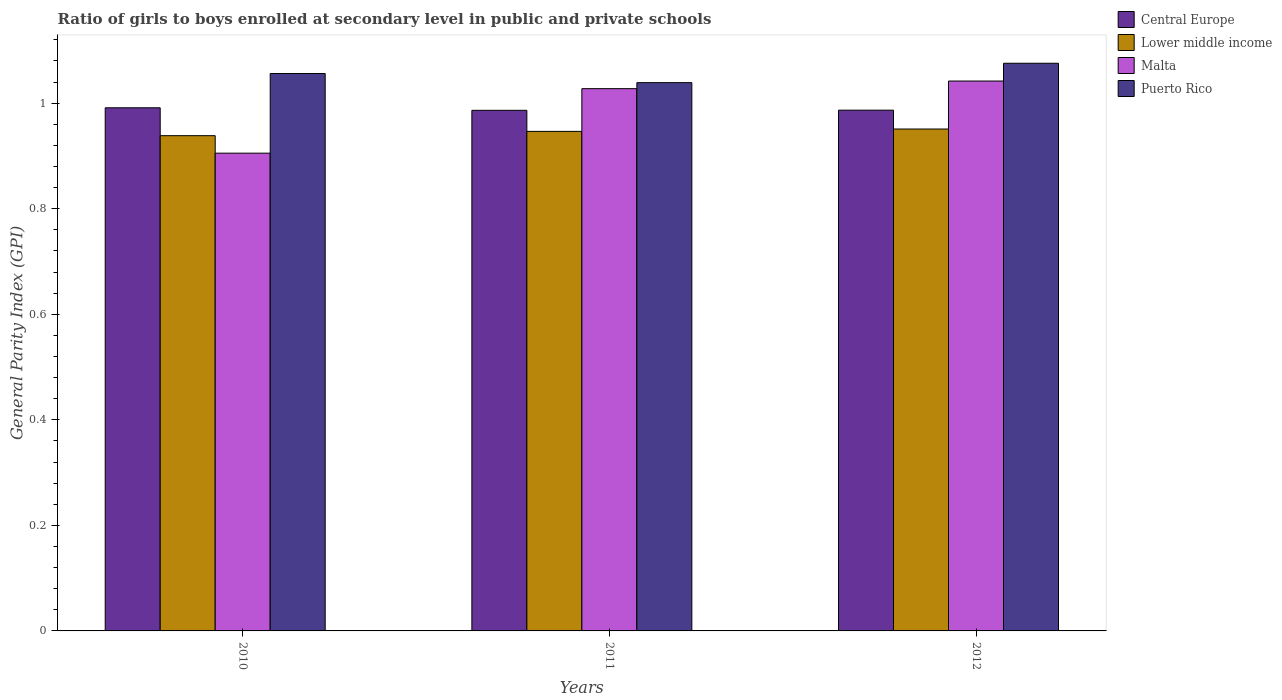How many different coloured bars are there?
Provide a short and direct response. 4. Are the number of bars per tick equal to the number of legend labels?
Give a very brief answer. Yes. Are the number of bars on each tick of the X-axis equal?
Make the answer very short. Yes. How many bars are there on the 3rd tick from the right?
Your response must be concise. 4. What is the general parity index in Lower middle income in 2010?
Offer a terse response. 0.94. Across all years, what is the maximum general parity index in Central Europe?
Provide a short and direct response. 0.99. Across all years, what is the minimum general parity index in Lower middle income?
Provide a short and direct response. 0.94. What is the total general parity index in Lower middle income in the graph?
Ensure brevity in your answer.  2.84. What is the difference between the general parity index in Lower middle income in 2010 and that in 2011?
Your answer should be very brief. -0.01. What is the difference between the general parity index in Lower middle income in 2010 and the general parity index in Central Europe in 2012?
Offer a terse response. -0.05. What is the average general parity index in Central Europe per year?
Offer a terse response. 0.99. In the year 2010, what is the difference between the general parity index in Lower middle income and general parity index in Puerto Rico?
Your answer should be compact. -0.12. What is the ratio of the general parity index in Malta in 2011 to that in 2012?
Your answer should be very brief. 0.99. Is the difference between the general parity index in Lower middle income in 2010 and 2011 greater than the difference between the general parity index in Puerto Rico in 2010 and 2011?
Keep it short and to the point. No. What is the difference between the highest and the second highest general parity index in Central Europe?
Provide a short and direct response. 0. What is the difference between the highest and the lowest general parity index in Central Europe?
Offer a very short reply. 0. What does the 4th bar from the left in 2010 represents?
Make the answer very short. Puerto Rico. What does the 1st bar from the right in 2012 represents?
Your answer should be very brief. Puerto Rico. Is it the case that in every year, the sum of the general parity index in Malta and general parity index in Puerto Rico is greater than the general parity index in Lower middle income?
Give a very brief answer. Yes. How many bars are there?
Provide a short and direct response. 12. What is the difference between two consecutive major ticks on the Y-axis?
Your response must be concise. 0.2. How many legend labels are there?
Your answer should be very brief. 4. What is the title of the graph?
Your answer should be compact. Ratio of girls to boys enrolled at secondary level in public and private schools. What is the label or title of the X-axis?
Offer a terse response. Years. What is the label or title of the Y-axis?
Your answer should be compact. General Parity Index (GPI). What is the General Parity Index (GPI) in Central Europe in 2010?
Provide a succinct answer. 0.99. What is the General Parity Index (GPI) in Lower middle income in 2010?
Keep it short and to the point. 0.94. What is the General Parity Index (GPI) in Malta in 2010?
Provide a short and direct response. 0.91. What is the General Parity Index (GPI) of Puerto Rico in 2010?
Ensure brevity in your answer.  1.06. What is the General Parity Index (GPI) of Central Europe in 2011?
Your answer should be compact. 0.99. What is the General Parity Index (GPI) in Lower middle income in 2011?
Your answer should be very brief. 0.95. What is the General Parity Index (GPI) in Malta in 2011?
Provide a succinct answer. 1.03. What is the General Parity Index (GPI) of Puerto Rico in 2011?
Ensure brevity in your answer.  1.04. What is the General Parity Index (GPI) in Central Europe in 2012?
Your answer should be compact. 0.99. What is the General Parity Index (GPI) in Lower middle income in 2012?
Make the answer very short. 0.95. What is the General Parity Index (GPI) in Malta in 2012?
Ensure brevity in your answer.  1.04. What is the General Parity Index (GPI) in Puerto Rico in 2012?
Ensure brevity in your answer.  1.08. Across all years, what is the maximum General Parity Index (GPI) in Central Europe?
Your answer should be compact. 0.99. Across all years, what is the maximum General Parity Index (GPI) in Lower middle income?
Your answer should be compact. 0.95. Across all years, what is the maximum General Parity Index (GPI) in Malta?
Keep it short and to the point. 1.04. Across all years, what is the maximum General Parity Index (GPI) in Puerto Rico?
Provide a short and direct response. 1.08. Across all years, what is the minimum General Parity Index (GPI) of Central Europe?
Provide a short and direct response. 0.99. Across all years, what is the minimum General Parity Index (GPI) of Lower middle income?
Make the answer very short. 0.94. Across all years, what is the minimum General Parity Index (GPI) in Malta?
Make the answer very short. 0.91. Across all years, what is the minimum General Parity Index (GPI) of Puerto Rico?
Keep it short and to the point. 1.04. What is the total General Parity Index (GPI) in Central Europe in the graph?
Keep it short and to the point. 2.96. What is the total General Parity Index (GPI) of Lower middle income in the graph?
Provide a succinct answer. 2.84. What is the total General Parity Index (GPI) of Malta in the graph?
Your answer should be compact. 2.98. What is the total General Parity Index (GPI) in Puerto Rico in the graph?
Offer a terse response. 3.17. What is the difference between the General Parity Index (GPI) of Central Europe in 2010 and that in 2011?
Provide a short and direct response. 0. What is the difference between the General Parity Index (GPI) of Lower middle income in 2010 and that in 2011?
Your answer should be compact. -0.01. What is the difference between the General Parity Index (GPI) of Malta in 2010 and that in 2011?
Your answer should be compact. -0.12. What is the difference between the General Parity Index (GPI) in Puerto Rico in 2010 and that in 2011?
Offer a very short reply. 0.02. What is the difference between the General Parity Index (GPI) in Central Europe in 2010 and that in 2012?
Offer a terse response. 0. What is the difference between the General Parity Index (GPI) of Lower middle income in 2010 and that in 2012?
Ensure brevity in your answer.  -0.01. What is the difference between the General Parity Index (GPI) of Malta in 2010 and that in 2012?
Offer a very short reply. -0.14. What is the difference between the General Parity Index (GPI) of Puerto Rico in 2010 and that in 2012?
Your response must be concise. -0.02. What is the difference between the General Parity Index (GPI) of Central Europe in 2011 and that in 2012?
Offer a terse response. -0. What is the difference between the General Parity Index (GPI) in Lower middle income in 2011 and that in 2012?
Provide a short and direct response. -0. What is the difference between the General Parity Index (GPI) in Malta in 2011 and that in 2012?
Offer a very short reply. -0.01. What is the difference between the General Parity Index (GPI) in Puerto Rico in 2011 and that in 2012?
Ensure brevity in your answer.  -0.04. What is the difference between the General Parity Index (GPI) in Central Europe in 2010 and the General Parity Index (GPI) in Lower middle income in 2011?
Your answer should be compact. 0.04. What is the difference between the General Parity Index (GPI) in Central Europe in 2010 and the General Parity Index (GPI) in Malta in 2011?
Provide a short and direct response. -0.04. What is the difference between the General Parity Index (GPI) in Central Europe in 2010 and the General Parity Index (GPI) in Puerto Rico in 2011?
Offer a very short reply. -0.05. What is the difference between the General Parity Index (GPI) of Lower middle income in 2010 and the General Parity Index (GPI) of Malta in 2011?
Provide a short and direct response. -0.09. What is the difference between the General Parity Index (GPI) of Lower middle income in 2010 and the General Parity Index (GPI) of Puerto Rico in 2011?
Make the answer very short. -0.1. What is the difference between the General Parity Index (GPI) in Malta in 2010 and the General Parity Index (GPI) in Puerto Rico in 2011?
Give a very brief answer. -0.13. What is the difference between the General Parity Index (GPI) in Central Europe in 2010 and the General Parity Index (GPI) in Lower middle income in 2012?
Keep it short and to the point. 0.04. What is the difference between the General Parity Index (GPI) of Central Europe in 2010 and the General Parity Index (GPI) of Malta in 2012?
Ensure brevity in your answer.  -0.05. What is the difference between the General Parity Index (GPI) of Central Europe in 2010 and the General Parity Index (GPI) of Puerto Rico in 2012?
Your answer should be compact. -0.08. What is the difference between the General Parity Index (GPI) in Lower middle income in 2010 and the General Parity Index (GPI) in Malta in 2012?
Ensure brevity in your answer.  -0.1. What is the difference between the General Parity Index (GPI) of Lower middle income in 2010 and the General Parity Index (GPI) of Puerto Rico in 2012?
Your response must be concise. -0.14. What is the difference between the General Parity Index (GPI) in Malta in 2010 and the General Parity Index (GPI) in Puerto Rico in 2012?
Provide a succinct answer. -0.17. What is the difference between the General Parity Index (GPI) of Central Europe in 2011 and the General Parity Index (GPI) of Lower middle income in 2012?
Provide a succinct answer. 0.04. What is the difference between the General Parity Index (GPI) in Central Europe in 2011 and the General Parity Index (GPI) in Malta in 2012?
Give a very brief answer. -0.06. What is the difference between the General Parity Index (GPI) of Central Europe in 2011 and the General Parity Index (GPI) of Puerto Rico in 2012?
Your answer should be compact. -0.09. What is the difference between the General Parity Index (GPI) in Lower middle income in 2011 and the General Parity Index (GPI) in Malta in 2012?
Make the answer very short. -0.1. What is the difference between the General Parity Index (GPI) of Lower middle income in 2011 and the General Parity Index (GPI) of Puerto Rico in 2012?
Give a very brief answer. -0.13. What is the difference between the General Parity Index (GPI) in Malta in 2011 and the General Parity Index (GPI) in Puerto Rico in 2012?
Offer a very short reply. -0.05. What is the average General Parity Index (GPI) in Central Europe per year?
Give a very brief answer. 0.99. What is the average General Parity Index (GPI) in Lower middle income per year?
Ensure brevity in your answer.  0.95. What is the average General Parity Index (GPI) of Malta per year?
Your answer should be very brief. 0.99. What is the average General Parity Index (GPI) in Puerto Rico per year?
Ensure brevity in your answer.  1.06. In the year 2010, what is the difference between the General Parity Index (GPI) of Central Europe and General Parity Index (GPI) of Lower middle income?
Give a very brief answer. 0.05. In the year 2010, what is the difference between the General Parity Index (GPI) of Central Europe and General Parity Index (GPI) of Malta?
Give a very brief answer. 0.09. In the year 2010, what is the difference between the General Parity Index (GPI) of Central Europe and General Parity Index (GPI) of Puerto Rico?
Give a very brief answer. -0.06. In the year 2010, what is the difference between the General Parity Index (GPI) in Lower middle income and General Parity Index (GPI) in Malta?
Make the answer very short. 0.03. In the year 2010, what is the difference between the General Parity Index (GPI) of Lower middle income and General Parity Index (GPI) of Puerto Rico?
Make the answer very short. -0.12. In the year 2010, what is the difference between the General Parity Index (GPI) in Malta and General Parity Index (GPI) in Puerto Rico?
Offer a terse response. -0.15. In the year 2011, what is the difference between the General Parity Index (GPI) in Central Europe and General Parity Index (GPI) in Lower middle income?
Offer a very short reply. 0.04. In the year 2011, what is the difference between the General Parity Index (GPI) of Central Europe and General Parity Index (GPI) of Malta?
Give a very brief answer. -0.04. In the year 2011, what is the difference between the General Parity Index (GPI) of Central Europe and General Parity Index (GPI) of Puerto Rico?
Provide a succinct answer. -0.05. In the year 2011, what is the difference between the General Parity Index (GPI) in Lower middle income and General Parity Index (GPI) in Malta?
Offer a very short reply. -0.08. In the year 2011, what is the difference between the General Parity Index (GPI) in Lower middle income and General Parity Index (GPI) in Puerto Rico?
Offer a very short reply. -0.09. In the year 2011, what is the difference between the General Parity Index (GPI) in Malta and General Parity Index (GPI) in Puerto Rico?
Your answer should be compact. -0.01. In the year 2012, what is the difference between the General Parity Index (GPI) in Central Europe and General Parity Index (GPI) in Lower middle income?
Give a very brief answer. 0.04. In the year 2012, what is the difference between the General Parity Index (GPI) of Central Europe and General Parity Index (GPI) of Malta?
Ensure brevity in your answer.  -0.06. In the year 2012, what is the difference between the General Parity Index (GPI) in Central Europe and General Parity Index (GPI) in Puerto Rico?
Give a very brief answer. -0.09. In the year 2012, what is the difference between the General Parity Index (GPI) of Lower middle income and General Parity Index (GPI) of Malta?
Your response must be concise. -0.09. In the year 2012, what is the difference between the General Parity Index (GPI) of Lower middle income and General Parity Index (GPI) of Puerto Rico?
Ensure brevity in your answer.  -0.12. In the year 2012, what is the difference between the General Parity Index (GPI) in Malta and General Parity Index (GPI) in Puerto Rico?
Your answer should be very brief. -0.03. What is the ratio of the General Parity Index (GPI) in Malta in 2010 to that in 2011?
Your response must be concise. 0.88. What is the ratio of the General Parity Index (GPI) of Puerto Rico in 2010 to that in 2011?
Your answer should be compact. 1.02. What is the ratio of the General Parity Index (GPI) in Malta in 2010 to that in 2012?
Make the answer very short. 0.87. What is the ratio of the General Parity Index (GPI) of Puerto Rico in 2010 to that in 2012?
Provide a succinct answer. 0.98. What is the ratio of the General Parity Index (GPI) of Central Europe in 2011 to that in 2012?
Make the answer very short. 1. What is the ratio of the General Parity Index (GPI) in Malta in 2011 to that in 2012?
Provide a short and direct response. 0.99. What is the ratio of the General Parity Index (GPI) in Puerto Rico in 2011 to that in 2012?
Provide a short and direct response. 0.97. What is the difference between the highest and the second highest General Parity Index (GPI) in Central Europe?
Make the answer very short. 0. What is the difference between the highest and the second highest General Parity Index (GPI) of Lower middle income?
Offer a very short reply. 0. What is the difference between the highest and the second highest General Parity Index (GPI) in Malta?
Your answer should be compact. 0.01. What is the difference between the highest and the second highest General Parity Index (GPI) in Puerto Rico?
Provide a short and direct response. 0.02. What is the difference between the highest and the lowest General Parity Index (GPI) in Central Europe?
Offer a terse response. 0. What is the difference between the highest and the lowest General Parity Index (GPI) in Lower middle income?
Offer a terse response. 0.01. What is the difference between the highest and the lowest General Parity Index (GPI) in Malta?
Give a very brief answer. 0.14. What is the difference between the highest and the lowest General Parity Index (GPI) of Puerto Rico?
Provide a succinct answer. 0.04. 